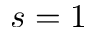Convert formula to latex. <formula><loc_0><loc_0><loc_500><loc_500>s = 1</formula> 